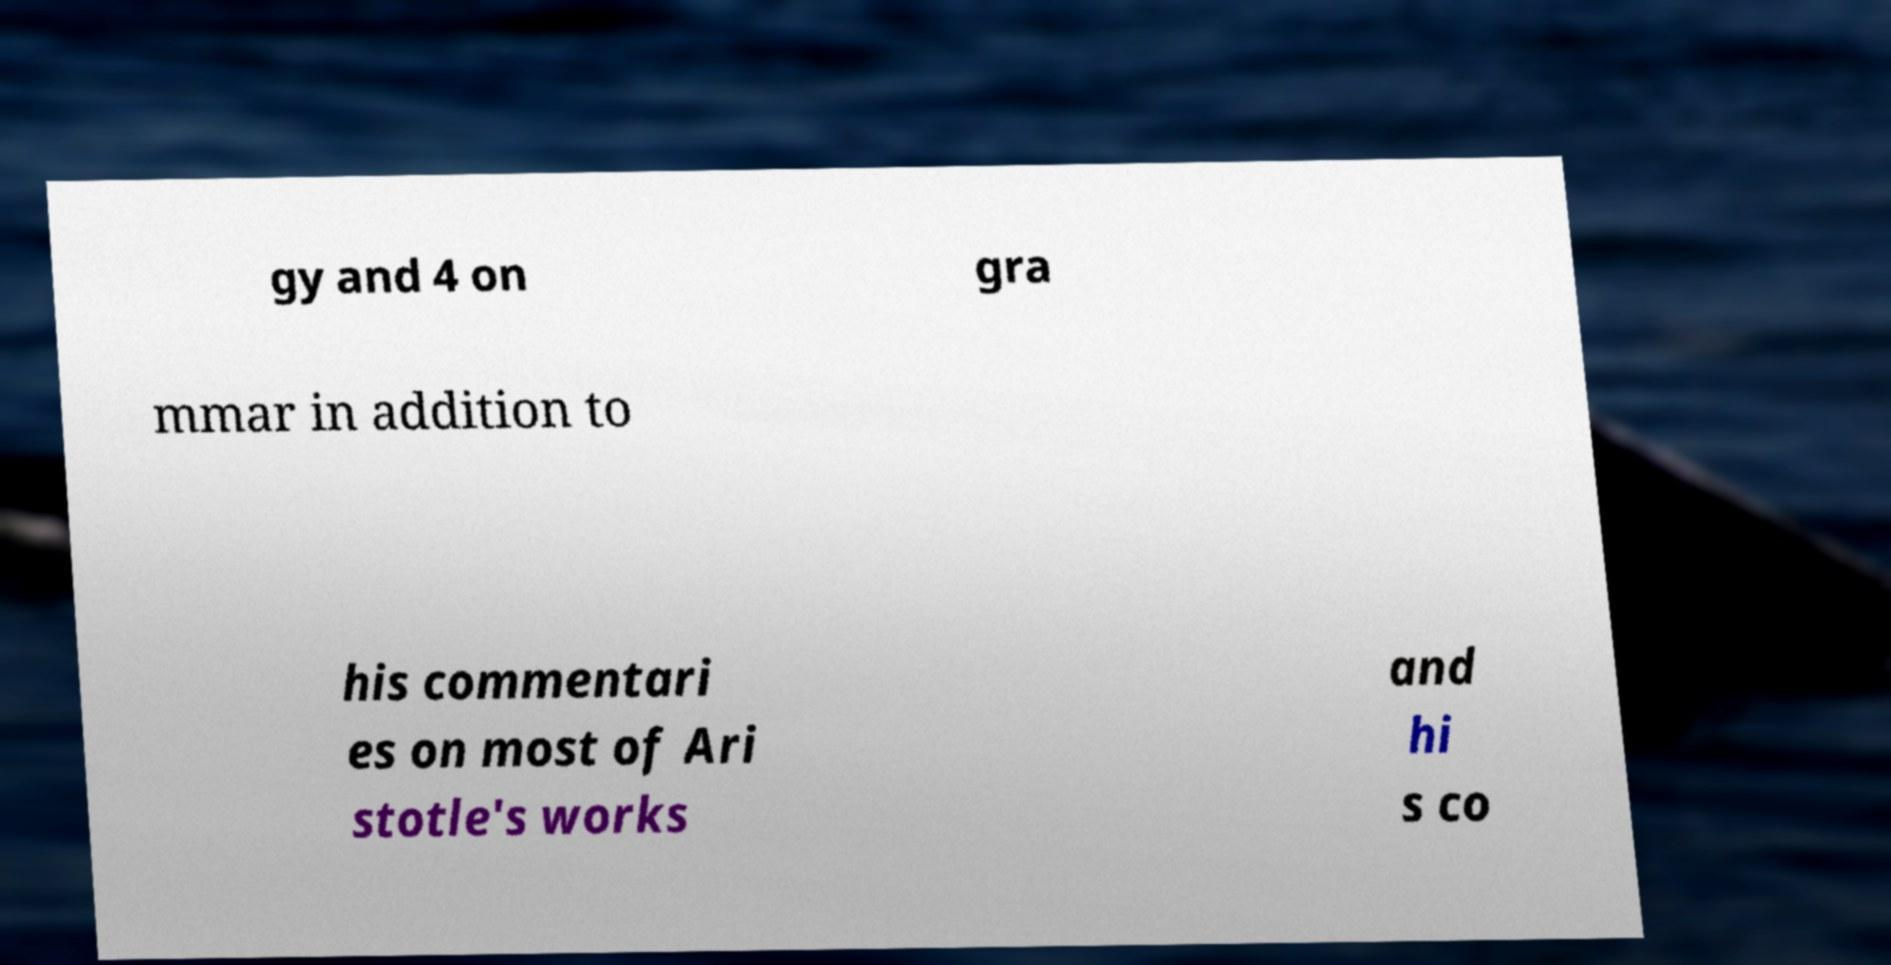I need the written content from this picture converted into text. Can you do that? gy and 4 on gra mmar in addition to his commentari es on most of Ari stotle's works and hi s co 